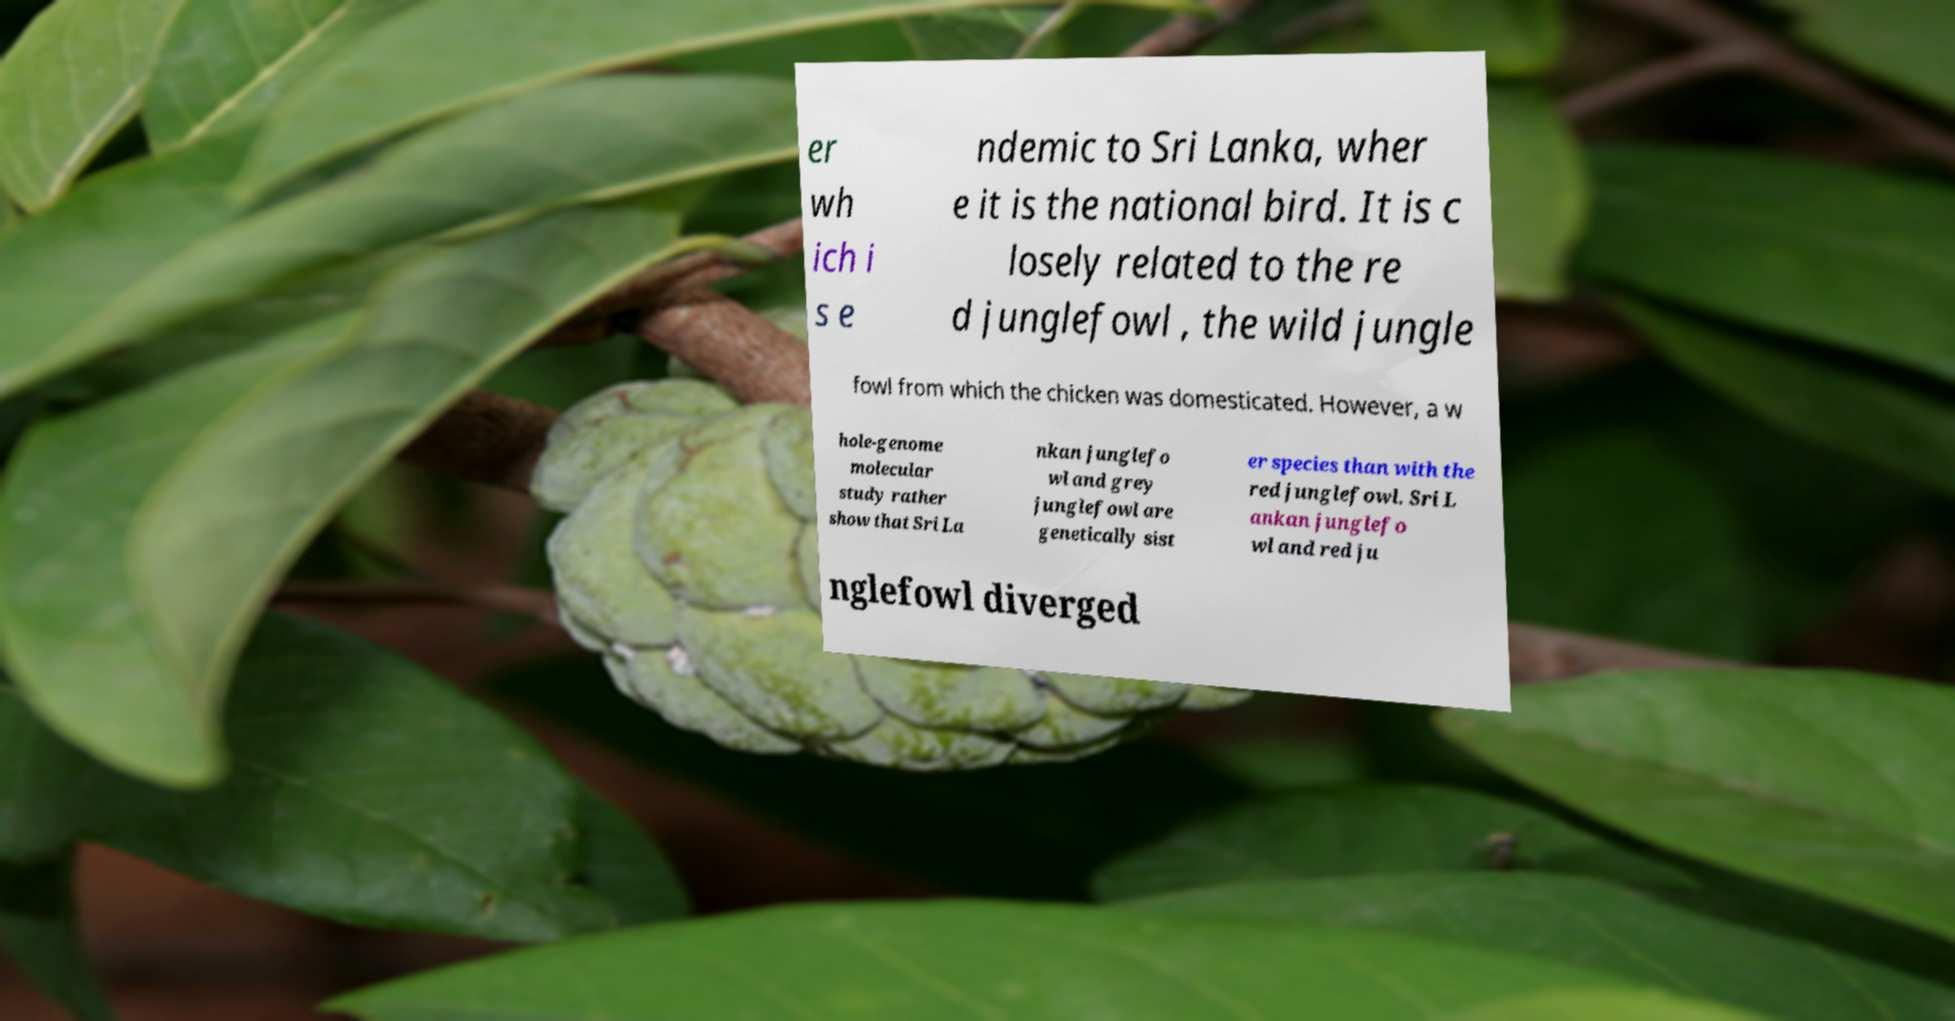Could you extract and type out the text from this image? er wh ich i s e ndemic to Sri Lanka, wher e it is the national bird. It is c losely related to the re d junglefowl , the wild jungle fowl from which the chicken was domesticated. However, a w hole-genome molecular study rather show that Sri La nkan junglefo wl and grey junglefowl are genetically sist er species than with the red junglefowl. Sri L ankan junglefo wl and red ju nglefowl diverged 